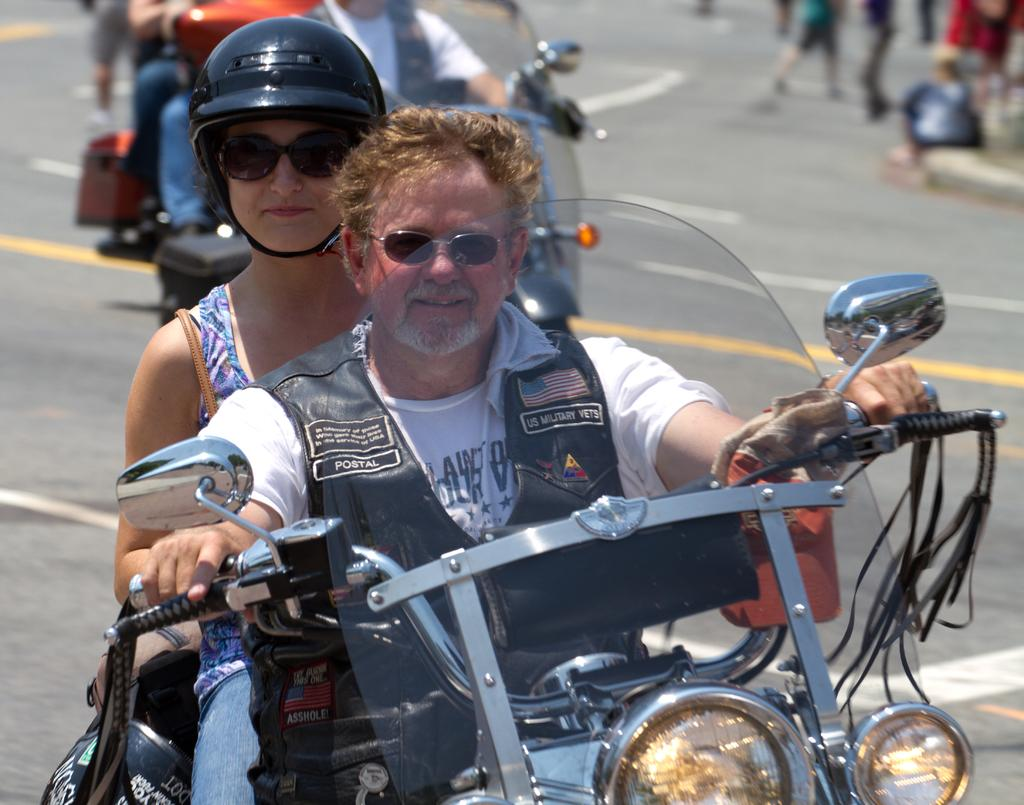How many people are in the image? There are two people in the image. What are the two people doing in the image? The two people are riding a bike. Can you describe one of the people in the image? One of the people is a woman. What safety precaution is the woman taking in the image? The woman is wearing a helmet. What type of branch is the woman holding in the image? There is no branch present in the image; the woman is wearing a helmet while riding a bike with another person. 